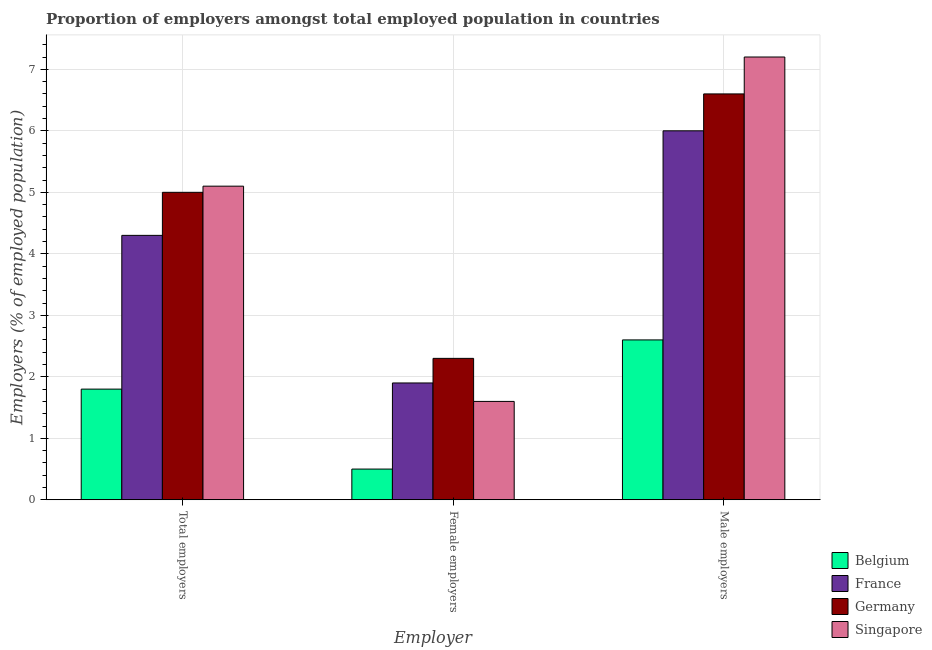How many different coloured bars are there?
Provide a succinct answer. 4. Are the number of bars per tick equal to the number of legend labels?
Make the answer very short. Yes. How many bars are there on the 1st tick from the left?
Your response must be concise. 4. How many bars are there on the 1st tick from the right?
Offer a terse response. 4. What is the label of the 2nd group of bars from the left?
Give a very brief answer. Female employers. What is the percentage of total employers in France?
Keep it short and to the point. 4.3. Across all countries, what is the maximum percentage of female employers?
Ensure brevity in your answer.  2.3. Across all countries, what is the minimum percentage of total employers?
Your response must be concise. 1.8. In which country was the percentage of total employers maximum?
Your answer should be very brief. Singapore. In which country was the percentage of male employers minimum?
Offer a terse response. Belgium. What is the total percentage of female employers in the graph?
Make the answer very short. 6.3. What is the difference between the percentage of total employers in Belgium and that in Germany?
Provide a short and direct response. -3.2. What is the difference between the percentage of female employers in Germany and the percentage of male employers in Belgium?
Offer a very short reply. -0.3. What is the average percentage of total employers per country?
Provide a succinct answer. 4.05. What is the difference between the percentage of total employers and percentage of female employers in Singapore?
Keep it short and to the point. 3.5. In how many countries, is the percentage of female employers greater than 1.4 %?
Make the answer very short. 3. What is the ratio of the percentage of total employers in Singapore to that in Germany?
Provide a short and direct response. 1.02. Is the percentage of female employers in France less than that in Belgium?
Ensure brevity in your answer.  No. What is the difference between the highest and the second highest percentage of total employers?
Keep it short and to the point. 0.1. What is the difference between the highest and the lowest percentage of total employers?
Provide a short and direct response. 3.3. In how many countries, is the percentage of male employers greater than the average percentage of male employers taken over all countries?
Your answer should be compact. 3. Is the sum of the percentage of male employers in Belgium and France greater than the maximum percentage of total employers across all countries?
Your answer should be compact. Yes. What does the 1st bar from the left in Male employers represents?
Offer a terse response. Belgium. What does the 1st bar from the right in Female employers represents?
Your answer should be very brief. Singapore. How many bars are there?
Your response must be concise. 12. Are all the bars in the graph horizontal?
Make the answer very short. No. How many countries are there in the graph?
Make the answer very short. 4. Does the graph contain grids?
Keep it short and to the point. Yes. Where does the legend appear in the graph?
Offer a terse response. Bottom right. How many legend labels are there?
Give a very brief answer. 4. How are the legend labels stacked?
Your response must be concise. Vertical. What is the title of the graph?
Ensure brevity in your answer.  Proportion of employers amongst total employed population in countries. Does "Belize" appear as one of the legend labels in the graph?
Your answer should be compact. No. What is the label or title of the X-axis?
Offer a very short reply. Employer. What is the label or title of the Y-axis?
Give a very brief answer. Employers (% of employed population). What is the Employers (% of employed population) of Belgium in Total employers?
Offer a very short reply. 1.8. What is the Employers (% of employed population) in France in Total employers?
Give a very brief answer. 4.3. What is the Employers (% of employed population) in Germany in Total employers?
Your answer should be very brief. 5. What is the Employers (% of employed population) of Singapore in Total employers?
Give a very brief answer. 5.1. What is the Employers (% of employed population) of Belgium in Female employers?
Make the answer very short. 0.5. What is the Employers (% of employed population) in France in Female employers?
Make the answer very short. 1.9. What is the Employers (% of employed population) in Germany in Female employers?
Offer a very short reply. 2.3. What is the Employers (% of employed population) in Singapore in Female employers?
Your response must be concise. 1.6. What is the Employers (% of employed population) of Belgium in Male employers?
Offer a very short reply. 2.6. What is the Employers (% of employed population) of France in Male employers?
Offer a very short reply. 6. What is the Employers (% of employed population) in Germany in Male employers?
Provide a succinct answer. 6.6. What is the Employers (% of employed population) in Singapore in Male employers?
Provide a short and direct response. 7.2. Across all Employer, what is the maximum Employers (% of employed population) of Belgium?
Give a very brief answer. 2.6. Across all Employer, what is the maximum Employers (% of employed population) in Germany?
Your response must be concise. 6.6. Across all Employer, what is the maximum Employers (% of employed population) of Singapore?
Provide a short and direct response. 7.2. Across all Employer, what is the minimum Employers (% of employed population) of Belgium?
Offer a very short reply. 0.5. Across all Employer, what is the minimum Employers (% of employed population) in France?
Offer a terse response. 1.9. Across all Employer, what is the minimum Employers (% of employed population) of Germany?
Make the answer very short. 2.3. Across all Employer, what is the minimum Employers (% of employed population) in Singapore?
Provide a succinct answer. 1.6. What is the difference between the Employers (% of employed population) of Singapore in Total employers and that in Female employers?
Keep it short and to the point. 3.5. What is the difference between the Employers (% of employed population) of France in Total employers and that in Male employers?
Offer a very short reply. -1.7. What is the difference between the Employers (% of employed population) in Belgium in Female employers and that in Male employers?
Offer a terse response. -2.1. What is the difference between the Employers (% of employed population) in France in Female employers and that in Male employers?
Make the answer very short. -4.1. What is the difference between the Employers (% of employed population) of Singapore in Female employers and that in Male employers?
Provide a succinct answer. -5.6. What is the difference between the Employers (% of employed population) in Belgium in Total employers and the Employers (% of employed population) in France in Female employers?
Your answer should be very brief. -0.1. What is the difference between the Employers (% of employed population) in Belgium in Total employers and the Employers (% of employed population) in Germany in Female employers?
Ensure brevity in your answer.  -0.5. What is the difference between the Employers (% of employed population) of France in Total employers and the Employers (% of employed population) of Germany in Female employers?
Ensure brevity in your answer.  2. What is the difference between the Employers (% of employed population) in Belgium in Total employers and the Employers (% of employed population) in Germany in Male employers?
Keep it short and to the point. -4.8. What is the difference between the Employers (% of employed population) of France in Total employers and the Employers (% of employed population) of Germany in Male employers?
Make the answer very short. -2.3. What is the difference between the Employers (% of employed population) of Belgium in Female employers and the Employers (% of employed population) of Singapore in Male employers?
Keep it short and to the point. -6.7. What is the difference between the Employers (% of employed population) of France in Female employers and the Employers (% of employed population) of Germany in Male employers?
Your response must be concise. -4.7. What is the difference between the Employers (% of employed population) in France in Female employers and the Employers (% of employed population) in Singapore in Male employers?
Your answer should be compact. -5.3. What is the average Employers (% of employed population) in Belgium per Employer?
Give a very brief answer. 1.63. What is the average Employers (% of employed population) in France per Employer?
Your answer should be compact. 4.07. What is the average Employers (% of employed population) in Germany per Employer?
Provide a short and direct response. 4.63. What is the average Employers (% of employed population) in Singapore per Employer?
Ensure brevity in your answer.  4.63. What is the difference between the Employers (% of employed population) of Belgium and Employers (% of employed population) of France in Total employers?
Give a very brief answer. -2.5. What is the difference between the Employers (% of employed population) of Belgium and Employers (% of employed population) of Germany in Total employers?
Give a very brief answer. -3.2. What is the difference between the Employers (% of employed population) of Belgium and Employers (% of employed population) of Singapore in Total employers?
Your answer should be very brief. -3.3. What is the difference between the Employers (% of employed population) of France and Employers (% of employed population) of Germany in Total employers?
Ensure brevity in your answer.  -0.7. What is the difference between the Employers (% of employed population) in France and Employers (% of employed population) in Singapore in Total employers?
Offer a very short reply. -0.8. What is the difference between the Employers (% of employed population) in Germany and Employers (% of employed population) in Singapore in Total employers?
Give a very brief answer. -0.1. What is the difference between the Employers (% of employed population) of Belgium and Employers (% of employed population) of France in Female employers?
Give a very brief answer. -1.4. What is the difference between the Employers (% of employed population) of Belgium and Employers (% of employed population) of Singapore in Female employers?
Ensure brevity in your answer.  -1.1. What is the difference between the Employers (% of employed population) of France and Employers (% of employed population) of Germany in Female employers?
Your answer should be very brief. -0.4. What is the difference between the Employers (% of employed population) in Belgium and Employers (% of employed population) in France in Male employers?
Offer a very short reply. -3.4. What is the difference between the Employers (% of employed population) in France and Employers (% of employed population) in Germany in Male employers?
Your response must be concise. -0.6. What is the difference between the Employers (% of employed population) of France and Employers (% of employed population) of Singapore in Male employers?
Provide a succinct answer. -1.2. What is the ratio of the Employers (% of employed population) in Belgium in Total employers to that in Female employers?
Provide a succinct answer. 3.6. What is the ratio of the Employers (% of employed population) in France in Total employers to that in Female employers?
Your answer should be compact. 2.26. What is the ratio of the Employers (% of employed population) of Germany in Total employers to that in Female employers?
Your answer should be compact. 2.17. What is the ratio of the Employers (% of employed population) in Singapore in Total employers to that in Female employers?
Offer a very short reply. 3.19. What is the ratio of the Employers (% of employed population) in Belgium in Total employers to that in Male employers?
Your response must be concise. 0.69. What is the ratio of the Employers (% of employed population) in France in Total employers to that in Male employers?
Ensure brevity in your answer.  0.72. What is the ratio of the Employers (% of employed population) of Germany in Total employers to that in Male employers?
Provide a succinct answer. 0.76. What is the ratio of the Employers (% of employed population) of Singapore in Total employers to that in Male employers?
Ensure brevity in your answer.  0.71. What is the ratio of the Employers (% of employed population) in Belgium in Female employers to that in Male employers?
Provide a short and direct response. 0.19. What is the ratio of the Employers (% of employed population) in France in Female employers to that in Male employers?
Your response must be concise. 0.32. What is the ratio of the Employers (% of employed population) of Germany in Female employers to that in Male employers?
Provide a short and direct response. 0.35. What is the ratio of the Employers (% of employed population) in Singapore in Female employers to that in Male employers?
Offer a terse response. 0.22. What is the difference between the highest and the second highest Employers (% of employed population) in Belgium?
Your answer should be very brief. 0.8. What is the difference between the highest and the second highest Employers (% of employed population) of France?
Your answer should be compact. 1.7. What is the difference between the highest and the second highest Employers (% of employed population) in Germany?
Keep it short and to the point. 1.6. What is the difference between the highest and the lowest Employers (% of employed population) of Belgium?
Offer a terse response. 2.1. What is the difference between the highest and the lowest Employers (% of employed population) of Germany?
Your answer should be very brief. 4.3. What is the difference between the highest and the lowest Employers (% of employed population) of Singapore?
Ensure brevity in your answer.  5.6. 